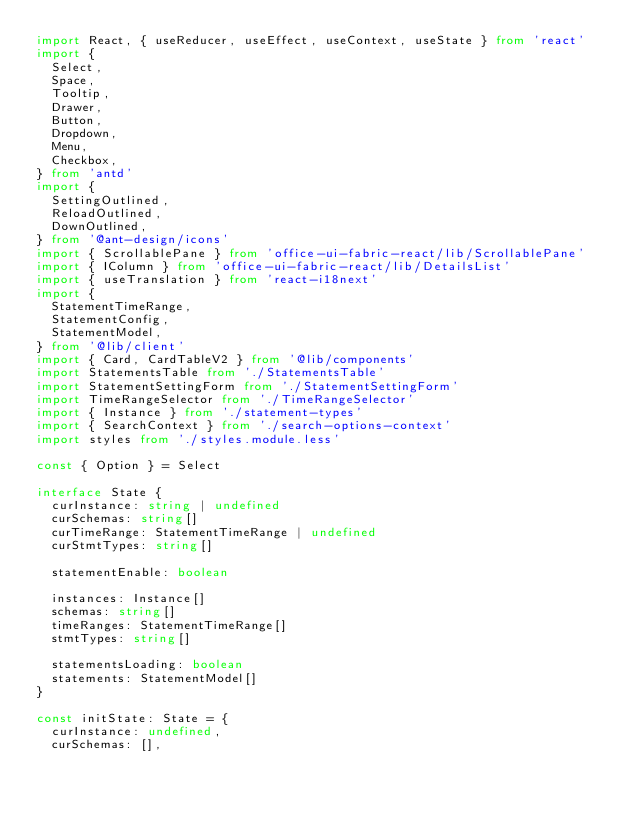Convert code to text. <code><loc_0><loc_0><loc_500><loc_500><_TypeScript_>import React, { useReducer, useEffect, useContext, useState } from 'react'
import {
  Select,
  Space,
  Tooltip,
  Drawer,
  Button,
  Dropdown,
  Menu,
  Checkbox,
} from 'antd'
import {
  SettingOutlined,
  ReloadOutlined,
  DownOutlined,
} from '@ant-design/icons'
import { ScrollablePane } from 'office-ui-fabric-react/lib/ScrollablePane'
import { IColumn } from 'office-ui-fabric-react/lib/DetailsList'
import { useTranslation } from 'react-i18next'
import {
  StatementTimeRange,
  StatementConfig,
  StatementModel,
} from '@lib/client'
import { Card, CardTableV2 } from '@lib/components'
import StatementsTable from './StatementsTable'
import StatementSettingForm from './StatementSettingForm'
import TimeRangeSelector from './TimeRangeSelector'
import { Instance } from './statement-types'
import { SearchContext } from './search-options-context'
import styles from './styles.module.less'

const { Option } = Select

interface State {
  curInstance: string | undefined
  curSchemas: string[]
  curTimeRange: StatementTimeRange | undefined
  curStmtTypes: string[]

  statementEnable: boolean

  instances: Instance[]
  schemas: string[]
  timeRanges: StatementTimeRange[]
  stmtTypes: string[]

  statementsLoading: boolean
  statements: StatementModel[]
}

const initState: State = {
  curInstance: undefined,
  curSchemas: [],</code> 